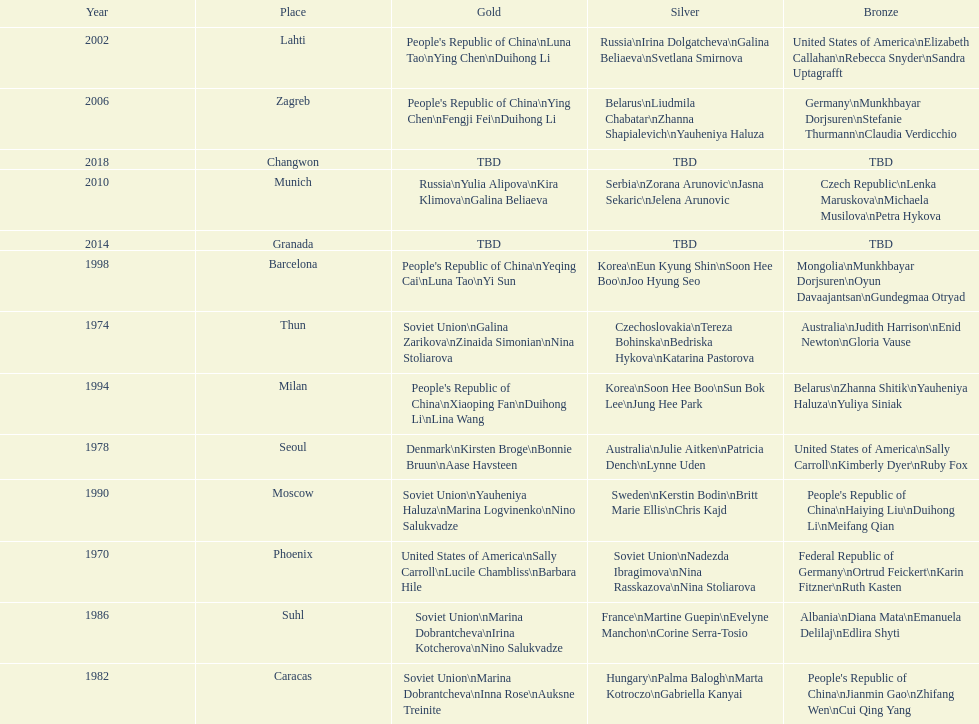How many times has germany won bronze? 2. 